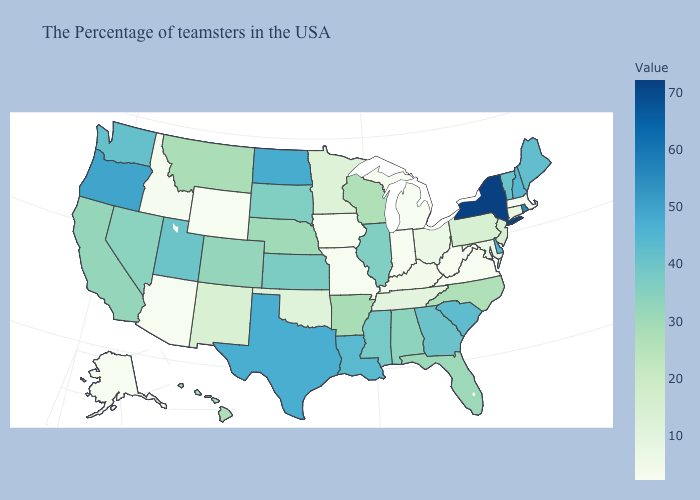Does Indiana have the lowest value in the MidWest?
Write a very short answer. Yes. Among the states that border Illinois , does Wisconsin have the highest value?
Quick response, please. Yes. Does Alabama have a higher value than New York?
Write a very short answer. No. Which states hav the highest value in the West?
Answer briefly. Oregon. Is the legend a continuous bar?
Be succinct. Yes. 